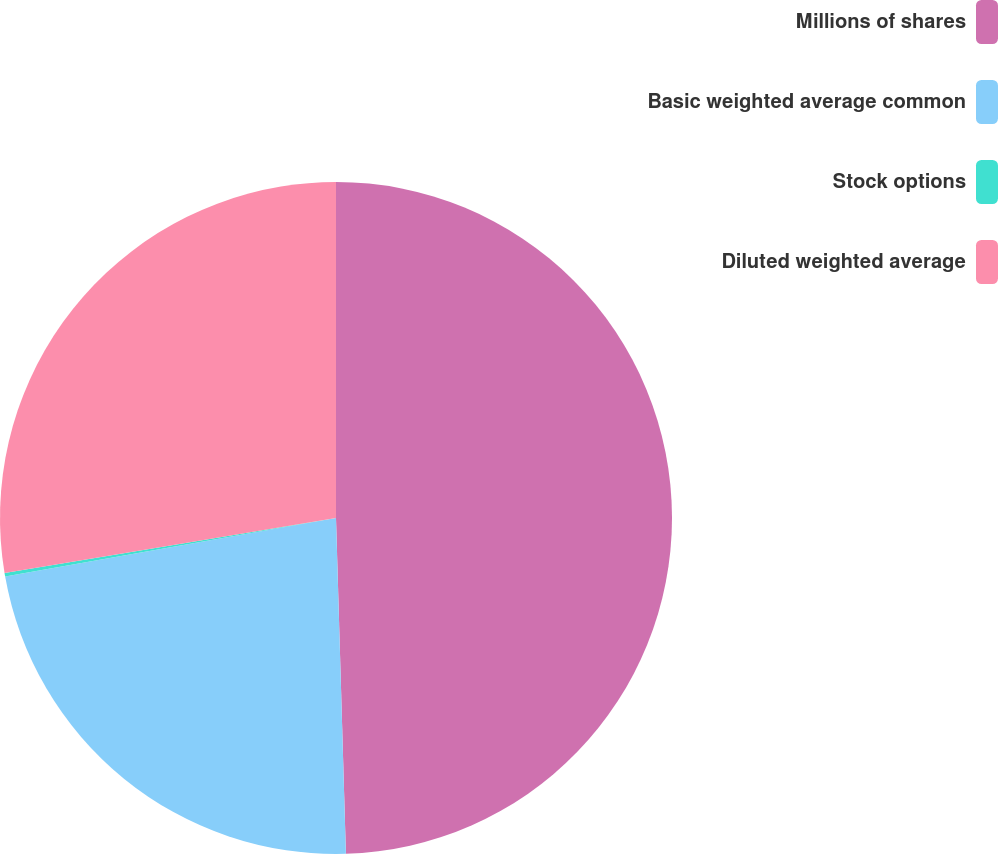<chart> <loc_0><loc_0><loc_500><loc_500><pie_chart><fcel>Millions of shares<fcel>Basic weighted average common<fcel>Stock options<fcel>Diluted weighted average<nl><fcel>49.53%<fcel>22.68%<fcel>0.17%<fcel>27.62%<nl></chart> 